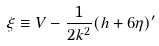Convert formula to latex. <formula><loc_0><loc_0><loc_500><loc_500>\xi \equiv V - \frac { 1 } { 2 k ^ { 2 } } ( h + 6 \eta ) ^ { \prime }</formula> 